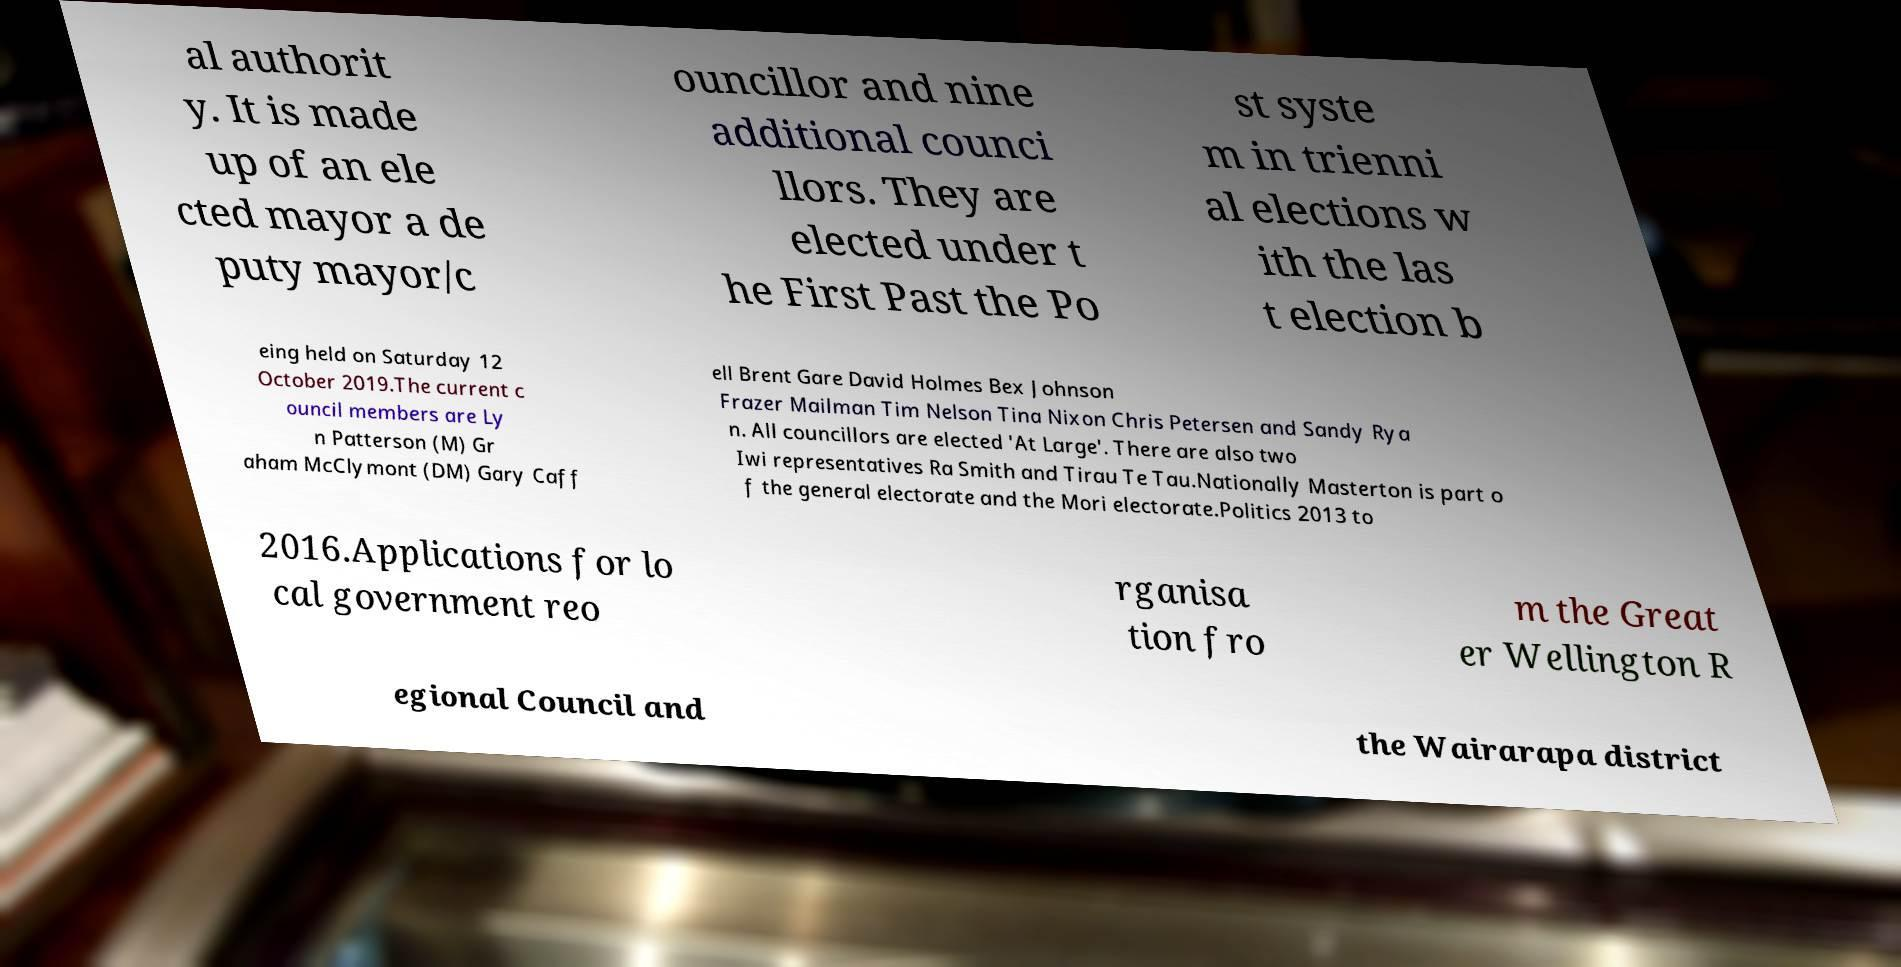I need the written content from this picture converted into text. Can you do that? al authorit y. It is made up of an ele cted mayor a de puty mayor/c ouncillor and nine additional counci llors. They are elected under t he First Past the Po st syste m in trienni al elections w ith the las t election b eing held on Saturday 12 October 2019.The current c ouncil members are Ly n Patterson (M) Gr aham McClymont (DM) Gary Caff ell Brent Gare David Holmes Bex Johnson Frazer Mailman Tim Nelson Tina Nixon Chris Petersen and Sandy Rya n. All councillors are elected 'At Large'. There are also two Iwi representatives Ra Smith and Tirau Te Tau.Nationally Masterton is part o f the general electorate and the Mori electorate.Politics 2013 to 2016.Applications for lo cal government reo rganisa tion fro m the Great er Wellington R egional Council and the Wairarapa district 